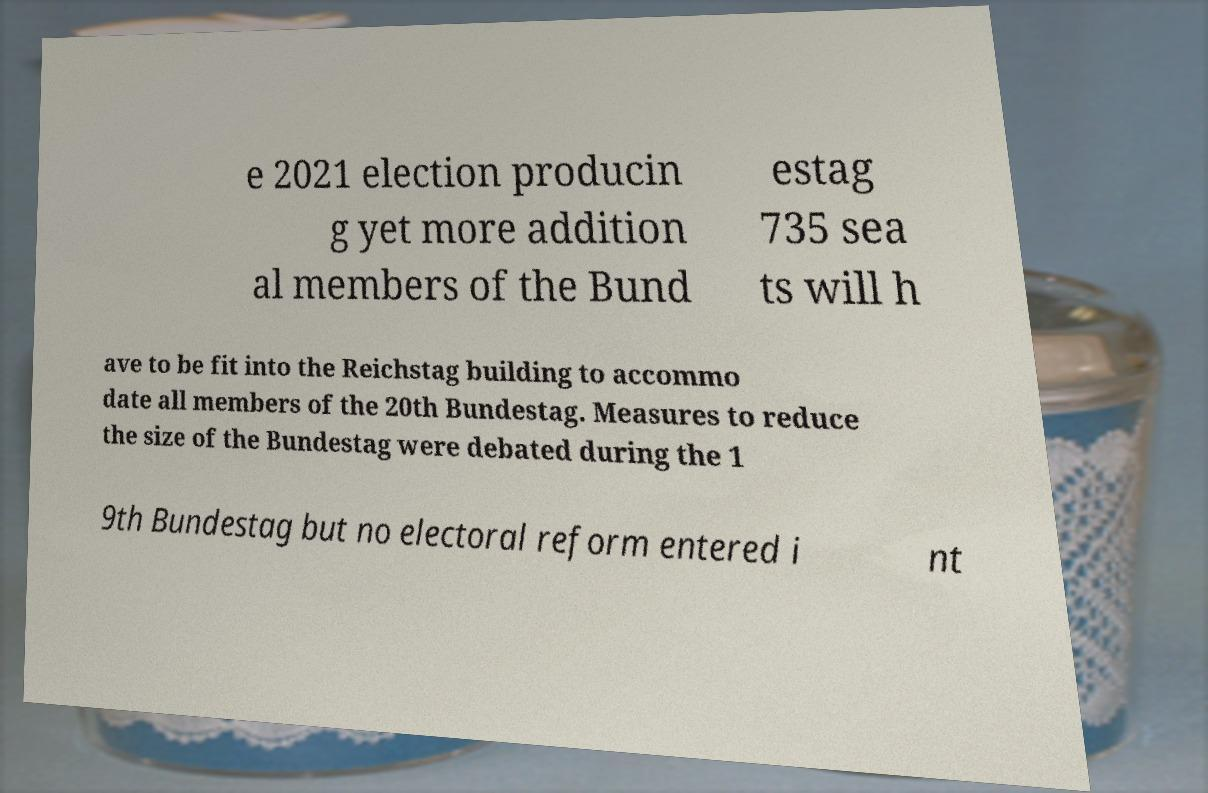There's text embedded in this image that I need extracted. Can you transcribe it verbatim? e 2021 election producin g yet more addition al members of the Bund estag 735 sea ts will h ave to be fit into the Reichstag building to accommo date all members of the 20th Bundestag. Measures to reduce the size of the Bundestag were debated during the 1 9th Bundestag but no electoral reform entered i nt 